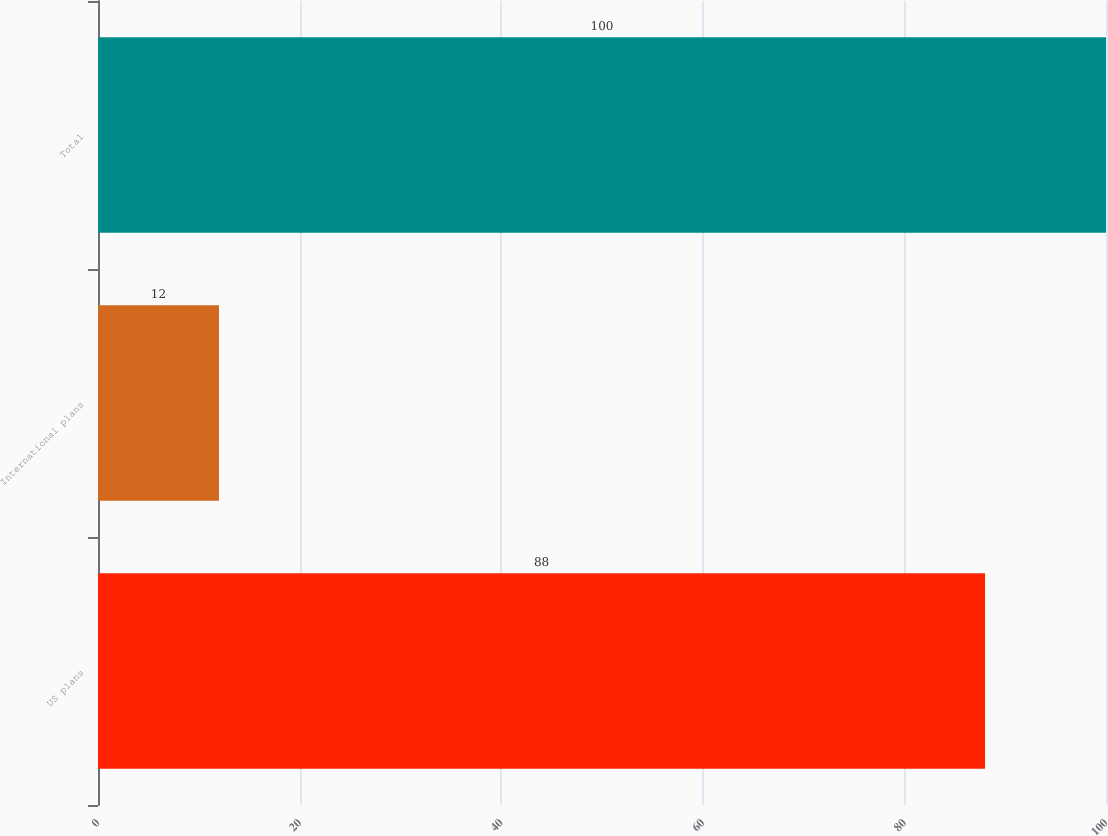<chart> <loc_0><loc_0><loc_500><loc_500><bar_chart><fcel>US plans<fcel>International plans<fcel>Total<nl><fcel>88<fcel>12<fcel>100<nl></chart> 